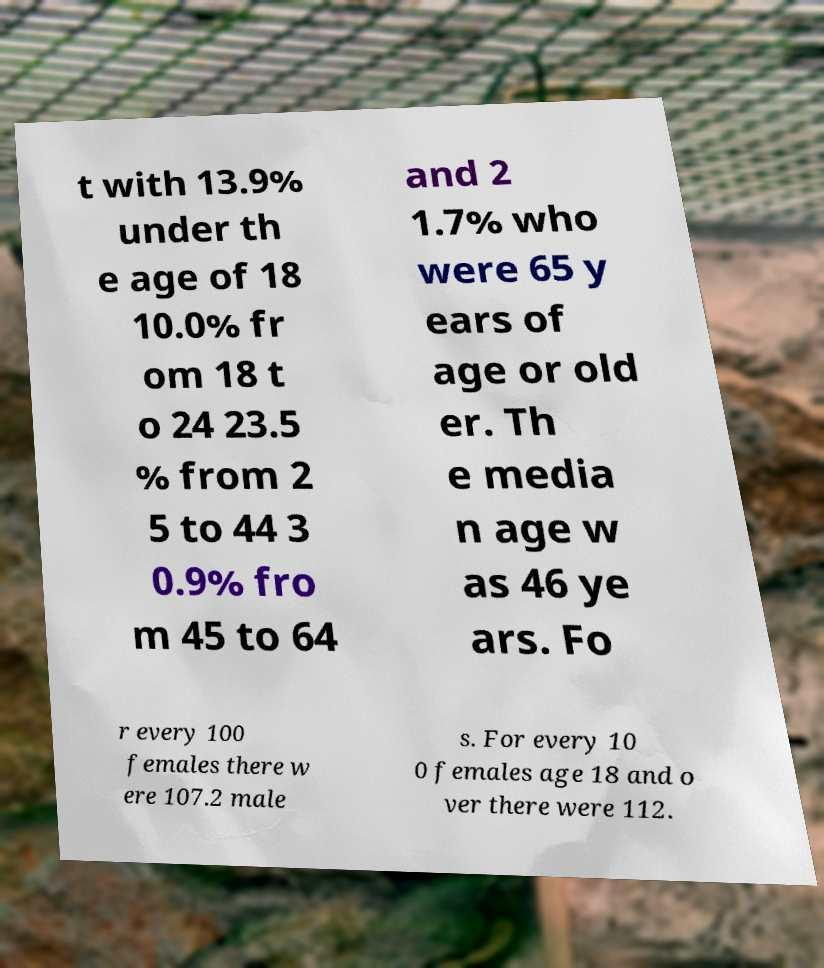I need the written content from this picture converted into text. Can you do that? t with 13.9% under th e age of 18 10.0% fr om 18 t o 24 23.5 % from 2 5 to 44 3 0.9% fro m 45 to 64 and 2 1.7% who were 65 y ears of age or old er. Th e media n age w as 46 ye ars. Fo r every 100 females there w ere 107.2 male s. For every 10 0 females age 18 and o ver there were 112. 